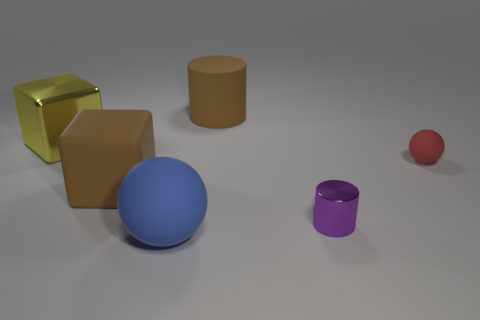Add 2 big rubber things. How many objects exist? 8 Subtract all blocks. How many objects are left? 4 Subtract 0 red cubes. How many objects are left? 6 Subtract all large brown objects. Subtract all red rubber spheres. How many objects are left? 3 Add 1 tiny red objects. How many tiny red objects are left? 2 Add 4 large gray cylinders. How many large gray cylinders exist? 4 